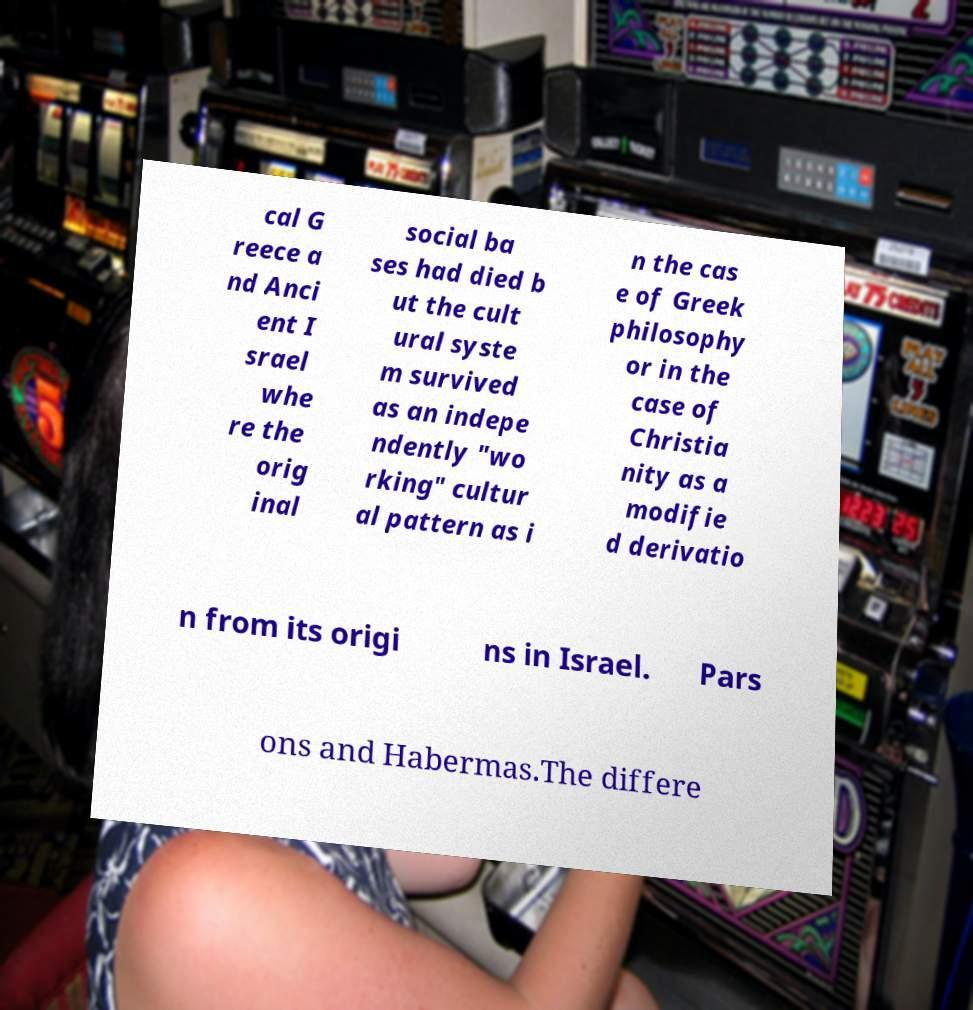Please read and relay the text visible in this image. What does it say? cal G reece a nd Anci ent I srael whe re the orig inal social ba ses had died b ut the cult ural syste m survived as an indepe ndently "wo rking" cultur al pattern as i n the cas e of Greek philosophy or in the case of Christia nity as a modifie d derivatio n from its origi ns in Israel. Pars ons and Habermas.The differe 